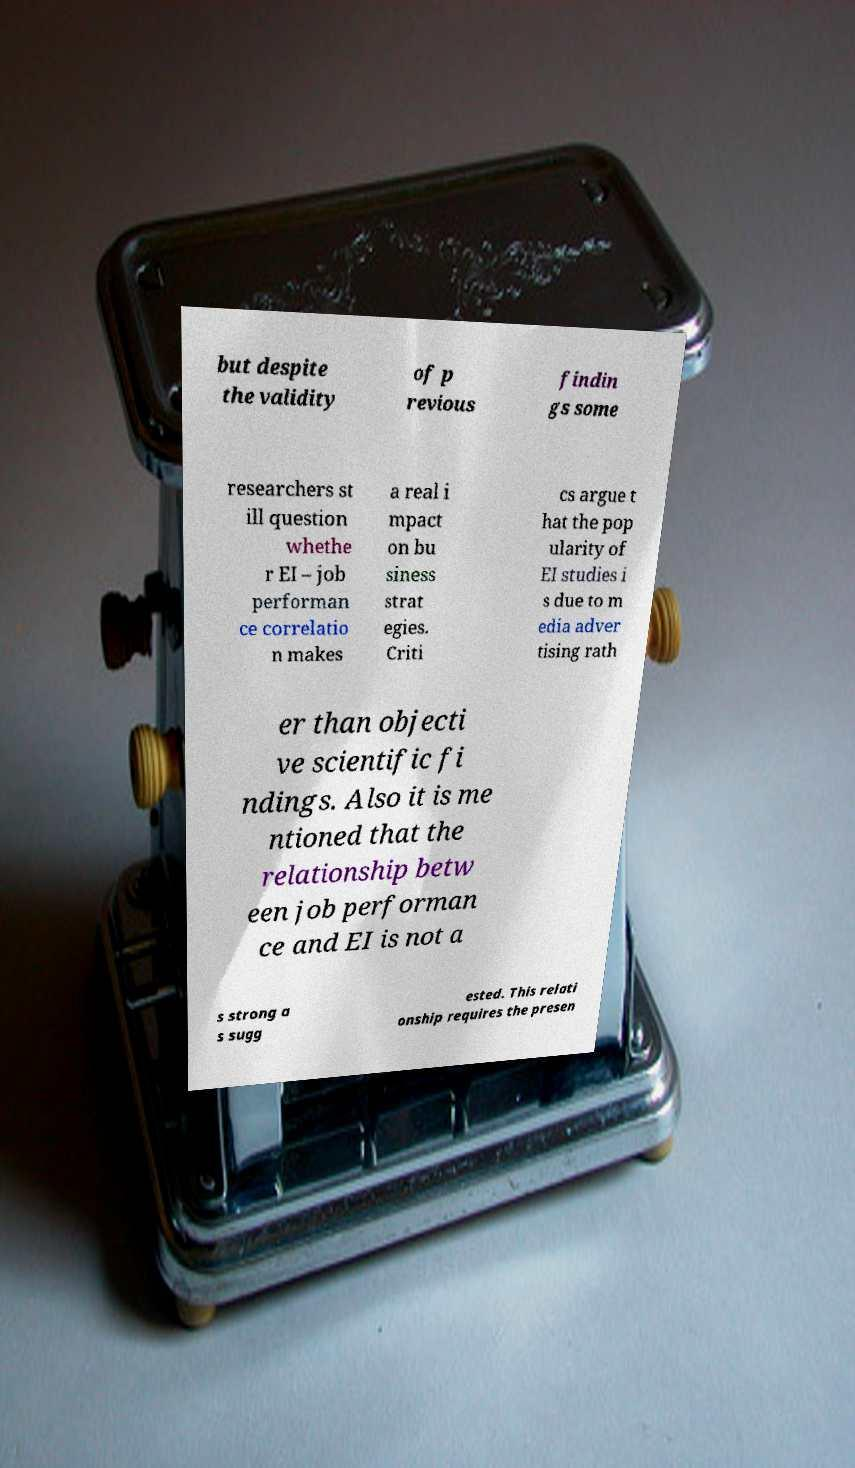Could you assist in decoding the text presented in this image and type it out clearly? but despite the validity of p revious findin gs some researchers st ill question whethe r EI – job performan ce correlatio n makes a real i mpact on bu siness strat egies. Criti cs argue t hat the pop ularity of EI studies i s due to m edia adver tising rath er than objecti ve scientific fi ndings. Also it is me ntioned that the relationship betw een job performan ce and EI is not a s strong a s sugg ested. This relati onship requires the presen 